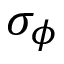Convert formula to latex. <formula><loc_0><loc_0><loc_500><loc_500>\sigma _ { \phi }</formula> 